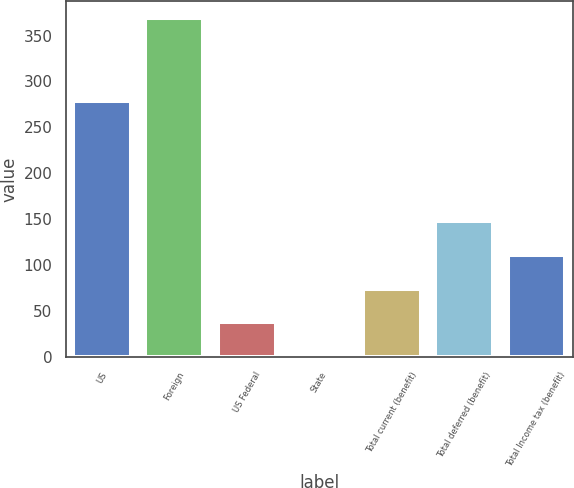<chart> <loc_0><loc_0><loc_500><loc_500><bar_chart><fcel>US<fcel>Foreign<fcel>US Federal<fcel>State<fcel>Total current (benefit)<fcel>Total deferred (benefit)<fcel>Total Income tax (benefit)<nl><fcel>279.3<fcel>369.1<fcel>37.81<fcel>1<fcel>74.62<fcel>148.24<fcel>111.43<nl></chart> 